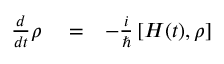<formula> <loc_0><loc_0><loc_500><loc_500>\begin{array} { r l r } { \frac { d } { d t } \rho } & = } & { - \frac { i } { } \left [ H ( t ) , \rho \right ] } \end{array}</formula> 